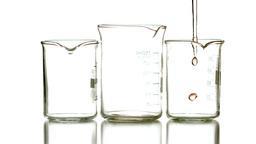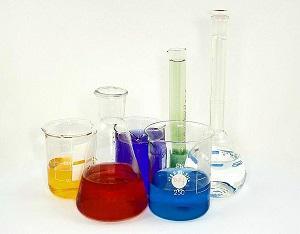The first image is the image on the left, the second image is the image on the right. Examine the images to the left and right. Is the description "Exactly eight clear empty beakers are divided into two groupings, one with five beakers of different sizes and the other with three of different sizes." accurate? Answer yes or no. No. The first image is the image on the left, the second image is the image on the right. Analyze the images presented: Is the assertion "An image contains exactly three empty measuring cups, which are arranged in one horizontal row." valid? Answer yes or no. Yes. 